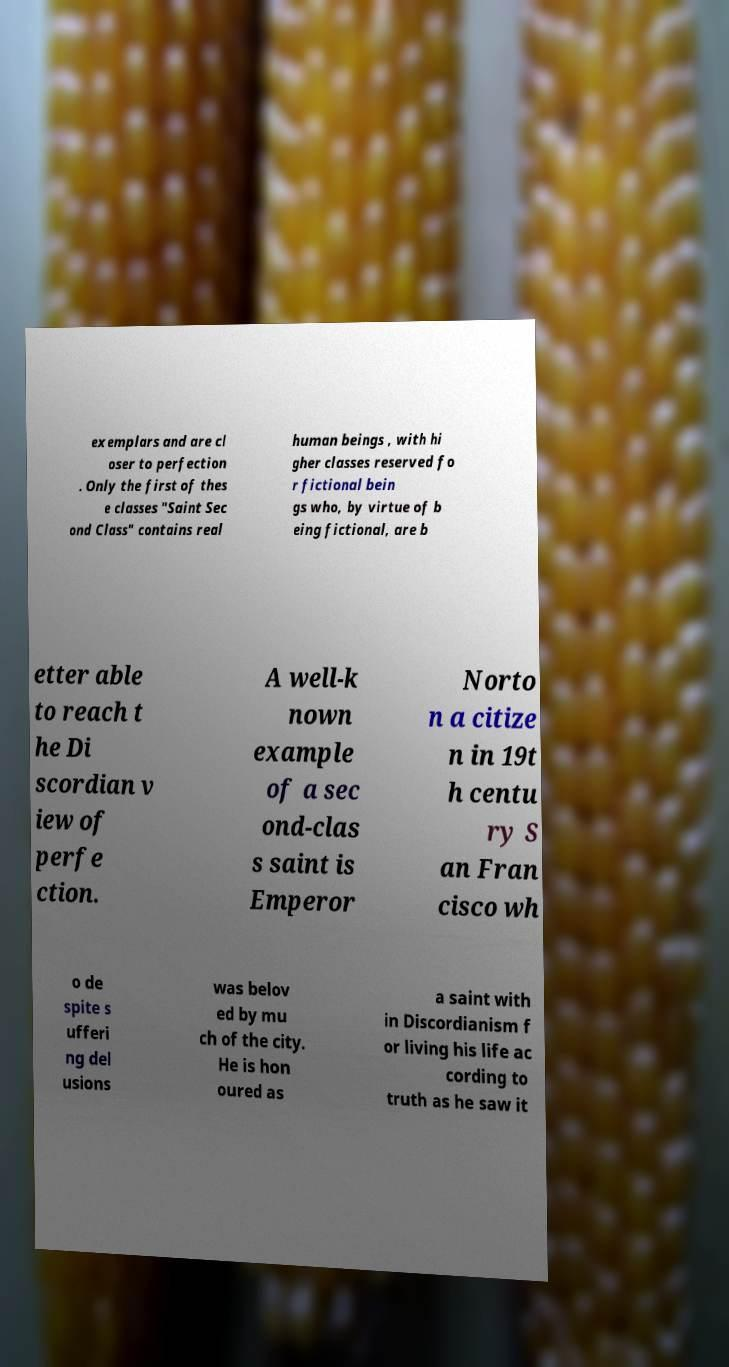What messages or text are displayed in this image? I need them in a readable, typed format. exemplars and are cl oser to perfection . Only the first of thes e classes "Saint Sec ond Class" contains real human beings , with hi gher classes reserved fo r fictional bein gs who, by virtue of b eing fictional, are b etter able to reach t he Di scordian v iew of perfe ction. A well-k nown example of a sec ond-clas s saint is Emperor Norto n a citize n in 19t h centu ry S an Fran cisco wh o de spite s ufferi ng del usions was belov ed by mu ch of the city. He is hon oured as a saint with in Discordianism f or living his life ac cording to truth as he saw it 